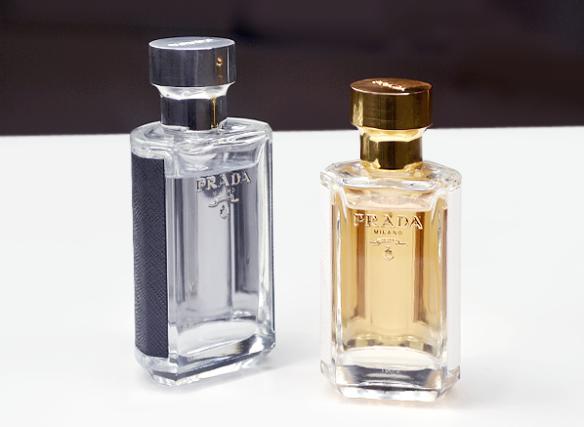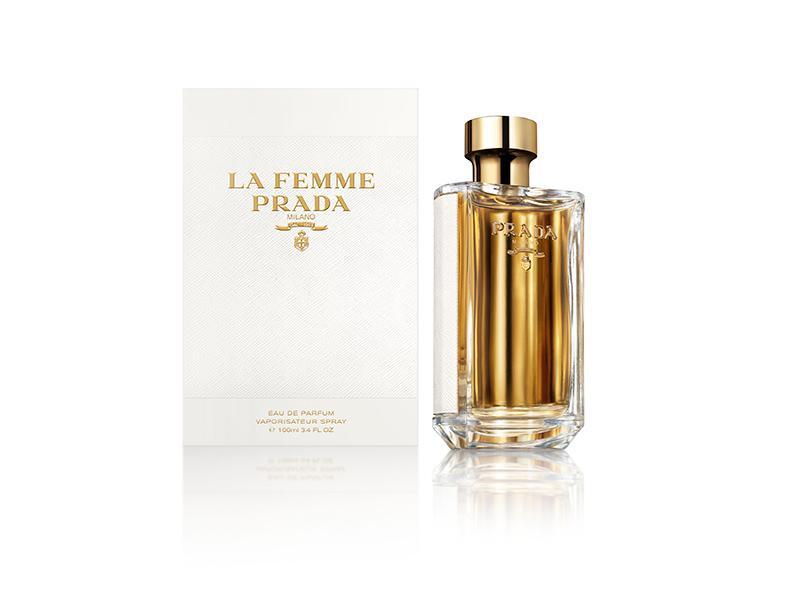The first image is the image on the left, the second image is the image on the right. For the images shown, is this caption "One image shows Prada perfume next to its box and the other shows Prada perfume without a box." true? Answer yes or no. Yes. 